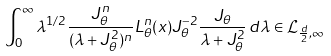Convert formula to latex. <formula><loc_0><loc_0><loc_500><loc_500>\int _ { 0 } ^ { \infty } \lambda ^ { 1 / 2 } \frac { J _ { \theta } ^ { n } } { ( \lambda + J _ { \theta } ^ { 2 } ) ^ { n } } L _ { \theta } ^ { n } ( x ) J _ { \theta } ^ { - 2 } \frac { J _ { \theta } } { \lambda + J _ { \theta } ^ { 2 } } \, d \lambda \in { \mathcal { L } } _ { \frac { d } { 2 } , \infty }</formula> 